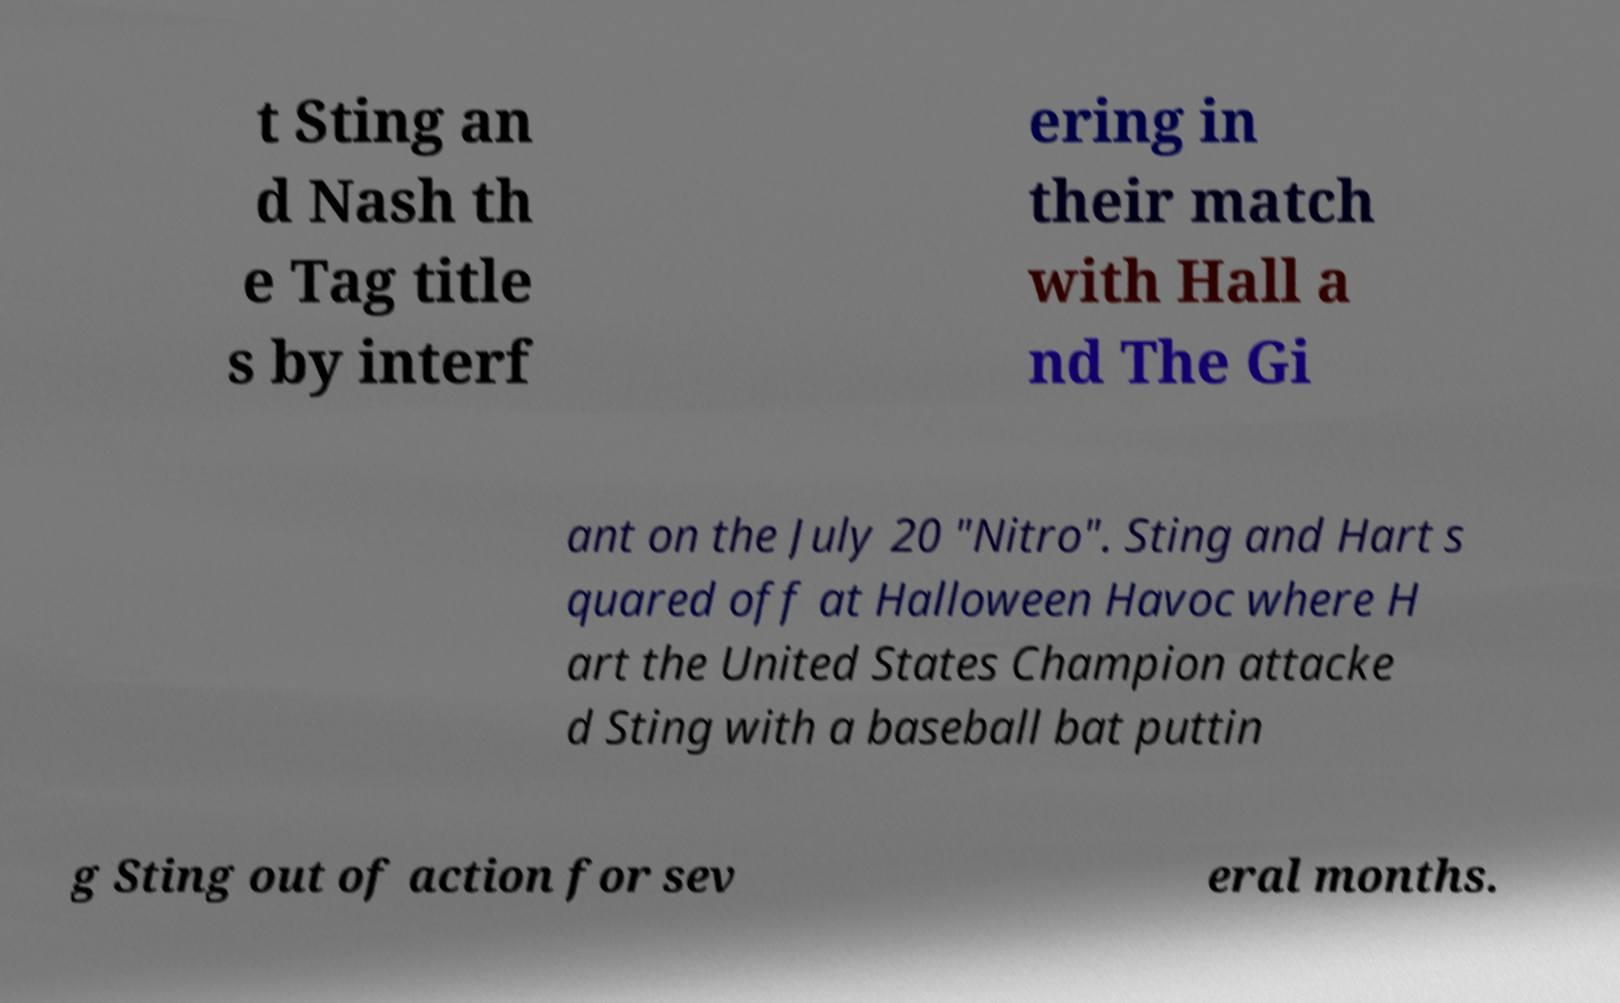Please read and relay the text visible in this image. What does it say? t Sting an d Nash th e Tag title s by interf ering in their match with Hall a nd The Gi ant on the July 20 "Nitro". Sting and Hart s quared off at Halloween Havoc where H art the United States Champion attacke d Sting with a baseball bat puttin g Sting out of action for sev eral months. 